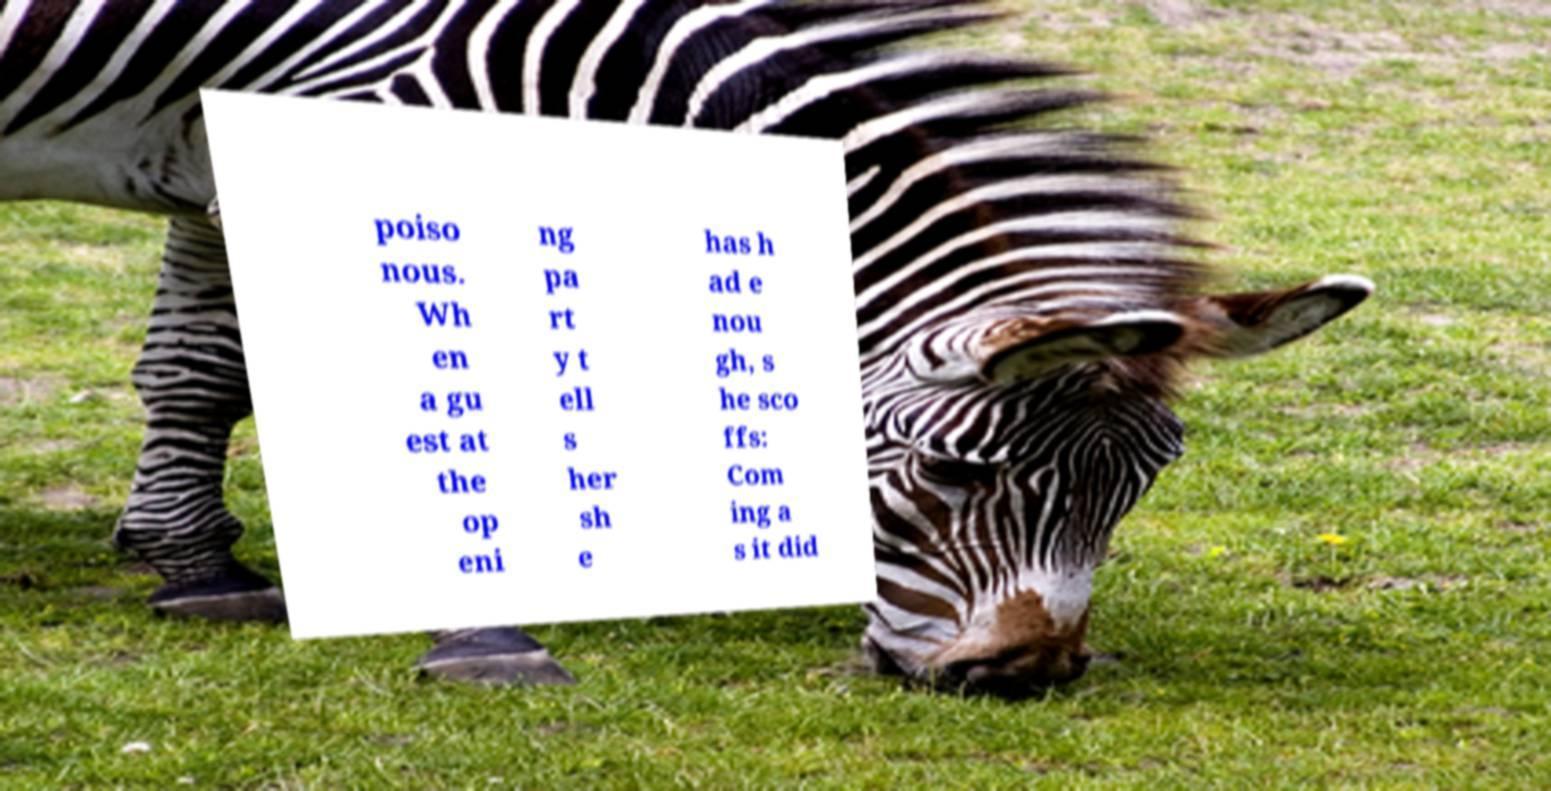What messages or text are displayed in this image? I need them in a readable, typed format. poiso nous. Wh en a gu est at the op eni ng pa rt y t ell s her sh e has h ad e nou gh, s he sco ffs: Com ing a s it did 